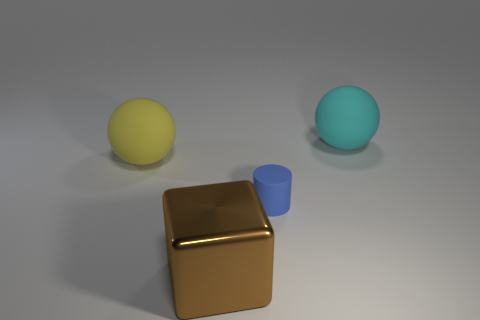Add 3 cylinders. How many objects exist? 7 Subtract all cubes. How many objects are left? 3 Subtract 0 brown spheres. How many objects are left? 4 Subtract all big yellow objects. Subtract all big cylinders. How many objects are left? 3 Add 1 small blue rubber objects. How many small blue rubber objects are left? 2 Add 4 rubber cylinders. How many rubber cylinders exist? 5 